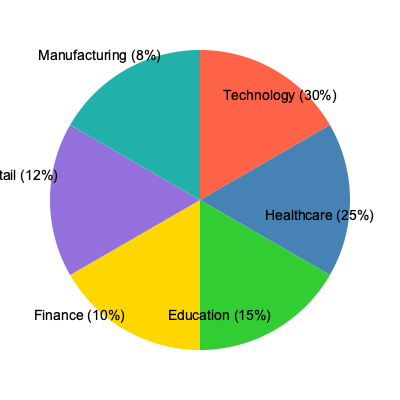Based on the pie chart showing job opportunities across different industries, which two sectors combined account for more than half of the available positions? To solve this question, we need to follow these steps:

1. Identify the percentages for each sector:
   - Technology: 30%
   - Healthcare: 25%
   - Education: 15%
   - Finance: 10%
   - Retail: 12%
   - Manufacturing: 8%

2. Find the two largest sectors:
   - Technology (30%)
   - Healthcare (25%)

3. Calculate the sum of these two sectors:
   $30\% + 25\% = 55\%$

4. Verify if this sum is greater than 50%:
   $55\% > 50\%$

5. Conclude that Technology and Healthcare combined account for more than half of the available positions.

This analysis is particularly relevant for a transfer student considering career options, as it highlights the industries with the most job opportunities.
Answer: Technology and Healthcare 